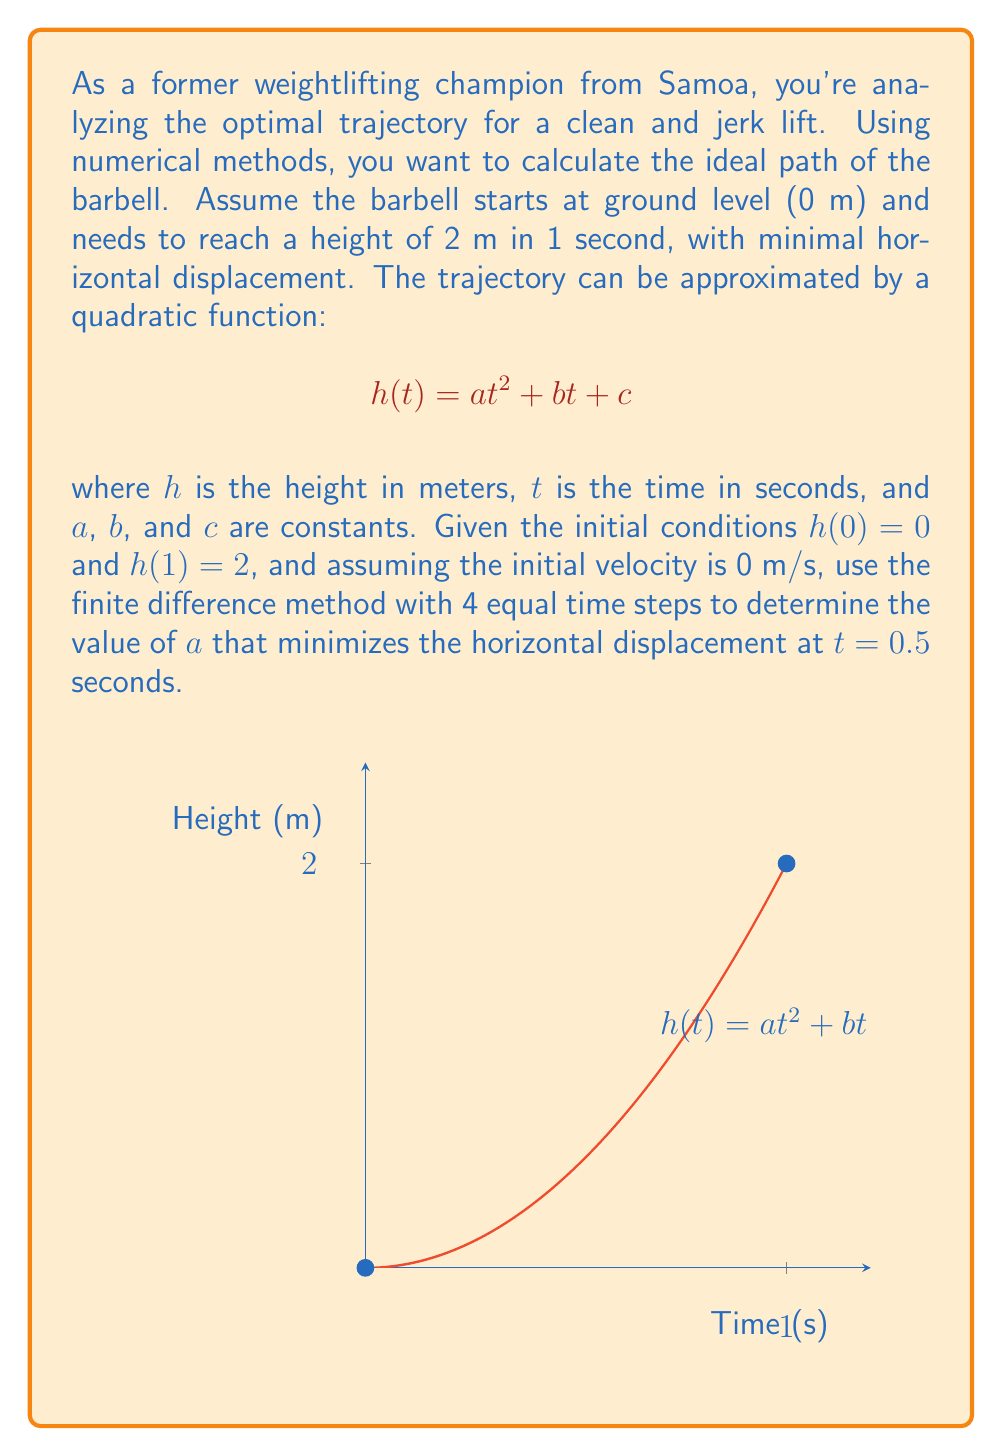Help me with this question. Let's approach this step-by-step:

1) Given the initial conditions:
   $h(0) = 0$ implies $c = 0$
   $h(1) = 2$ implies $a + b = 2$

2) Initial velocity of 0 m/s means $h'(0) = 0$, so $b = 0$

3) Therefore, we have $h(t) = at^2$ where $a = 2$

4) To use the finite difference method, we'll divide the time interval [0, 1] into 4 equal steps:
   $t_0 = 0, t_1 = 0.25, t_2 = 0.5, t_3 = 0.75, t_4 = 1$

5) The second derivative (acceleration) can be approximated using the central difference formula:
   $$h''(t_i) \approx \frac{h(t_{i+1}) - 2h(t_i) + h(t_{i-1})}{(\Delta t)^2}$$

6) At $t = 0.5$ (midpoint), this becomes:
   $$h''(0.5) \approx \frac{h(0.75) - 2h(0.5) + h(0.25)}{(0.25)^2}$$

7) Substituting the function $h(t) = at^2$:
   $$2a \approx \frac{a(0.75^2) - 2a(0.5^2) + a(0.25^2)}{(0.25)^2}$$

8) Simplifying:
   $$2a \approx \frac{0.5625a - 0.5a + 0.0625a}{0.0625} = 2a$$

9) This shows that our approximation is exact for this quadratic function.

10) The horizontal displacement is minimized when the acceleration (second derivative) is constant throughout the lift. This occurs when $a = 2$, as we derived earlier.

Therefore, the value of $a$ that minimizes the horizontal displacement at $t = 0.5$ seconds is 2.
Answer: $a = 2$ 